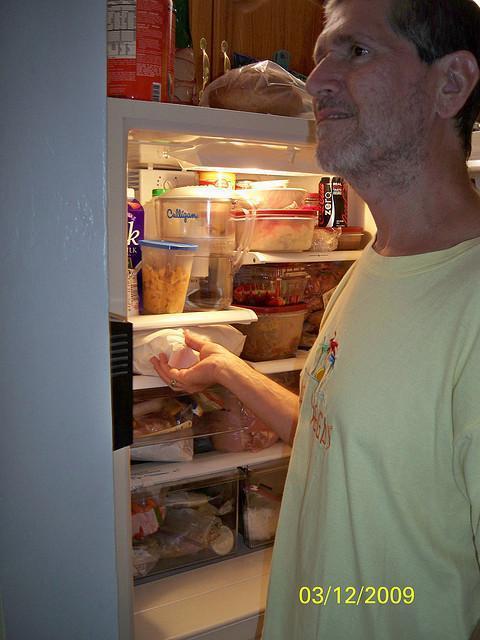How many refrigerators are there?
Give a very brief answer. 1. How many teddy bears are wearing a hair bow?
Give a very brief answer. 0. 